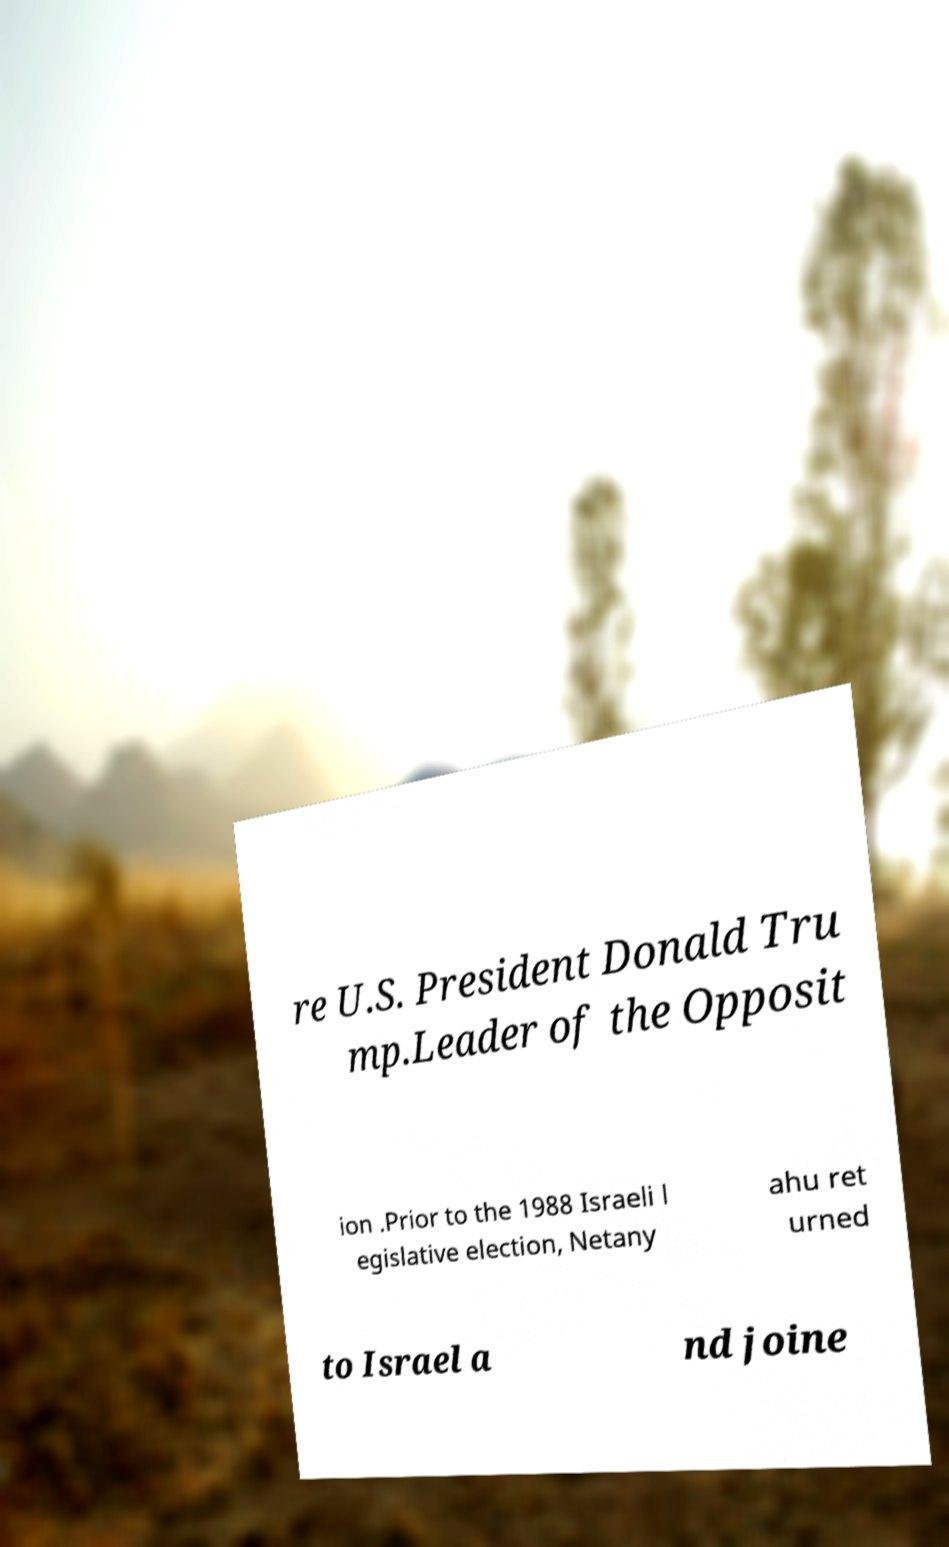Can you accurately transcribe the text from the provided image for me? re U.S. President Donald Tru mp.Leader of the Opposit ion .Prior to the 1988 Israeli l egislative election, Netany ahu ret urned to Israel a nd joine 